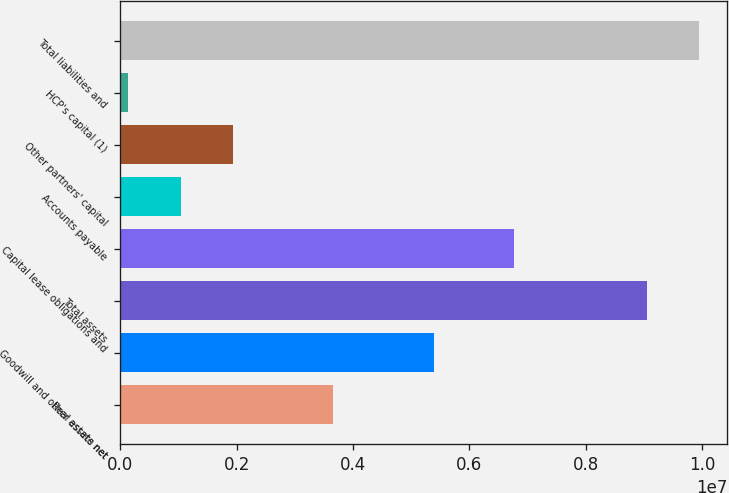<chart> <loc_0><loc_0><loc_500><loc_500><bar_chart><fcel>Real estate net<fcel>Goodwill and other assets net<fcel>Total assets<fcel>Capital lease obligations and<fcel>Accounts payable<fcel>Other partners' capital<fcel>HCP's capital (1)<fcel>Total liabilities and<nl><fcel>3.66245e+06<fcel>5.38455e+06<fcel>9.047e+06<fcel>6.76882e+06<fcel>1.04526e+06<fcel>1.93649e+06<fcel>134700<fcel>9.93823e+06<nl></chart> 